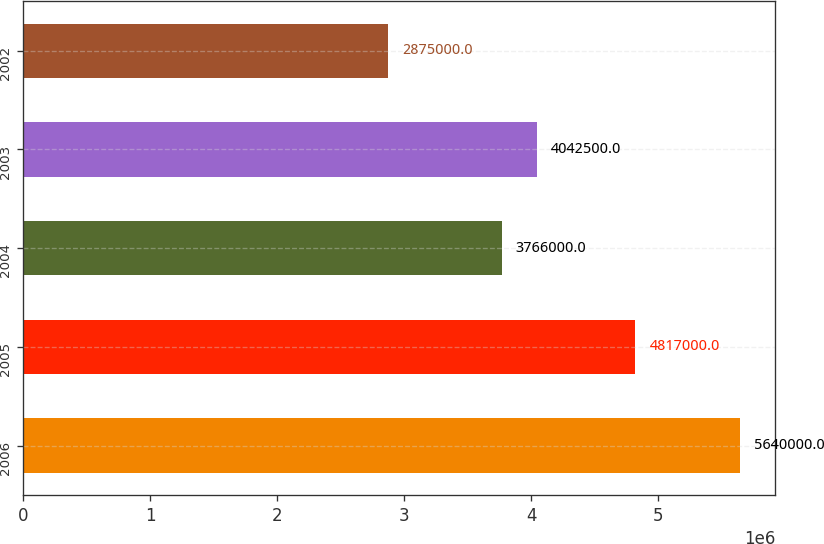Convert chart. <chart><loc_0><loc_0><loc_500><loc_500><bar_chart><fcel>2006<fcel>2005<fcel>2004<fcel>2003<fcel>2002<nl><fcel>5.64e+06<fcel>4.817e+06<fcel>3.766e+06<fcel>4.0425e+06<fcel>2.875e+06<nl></chart> 